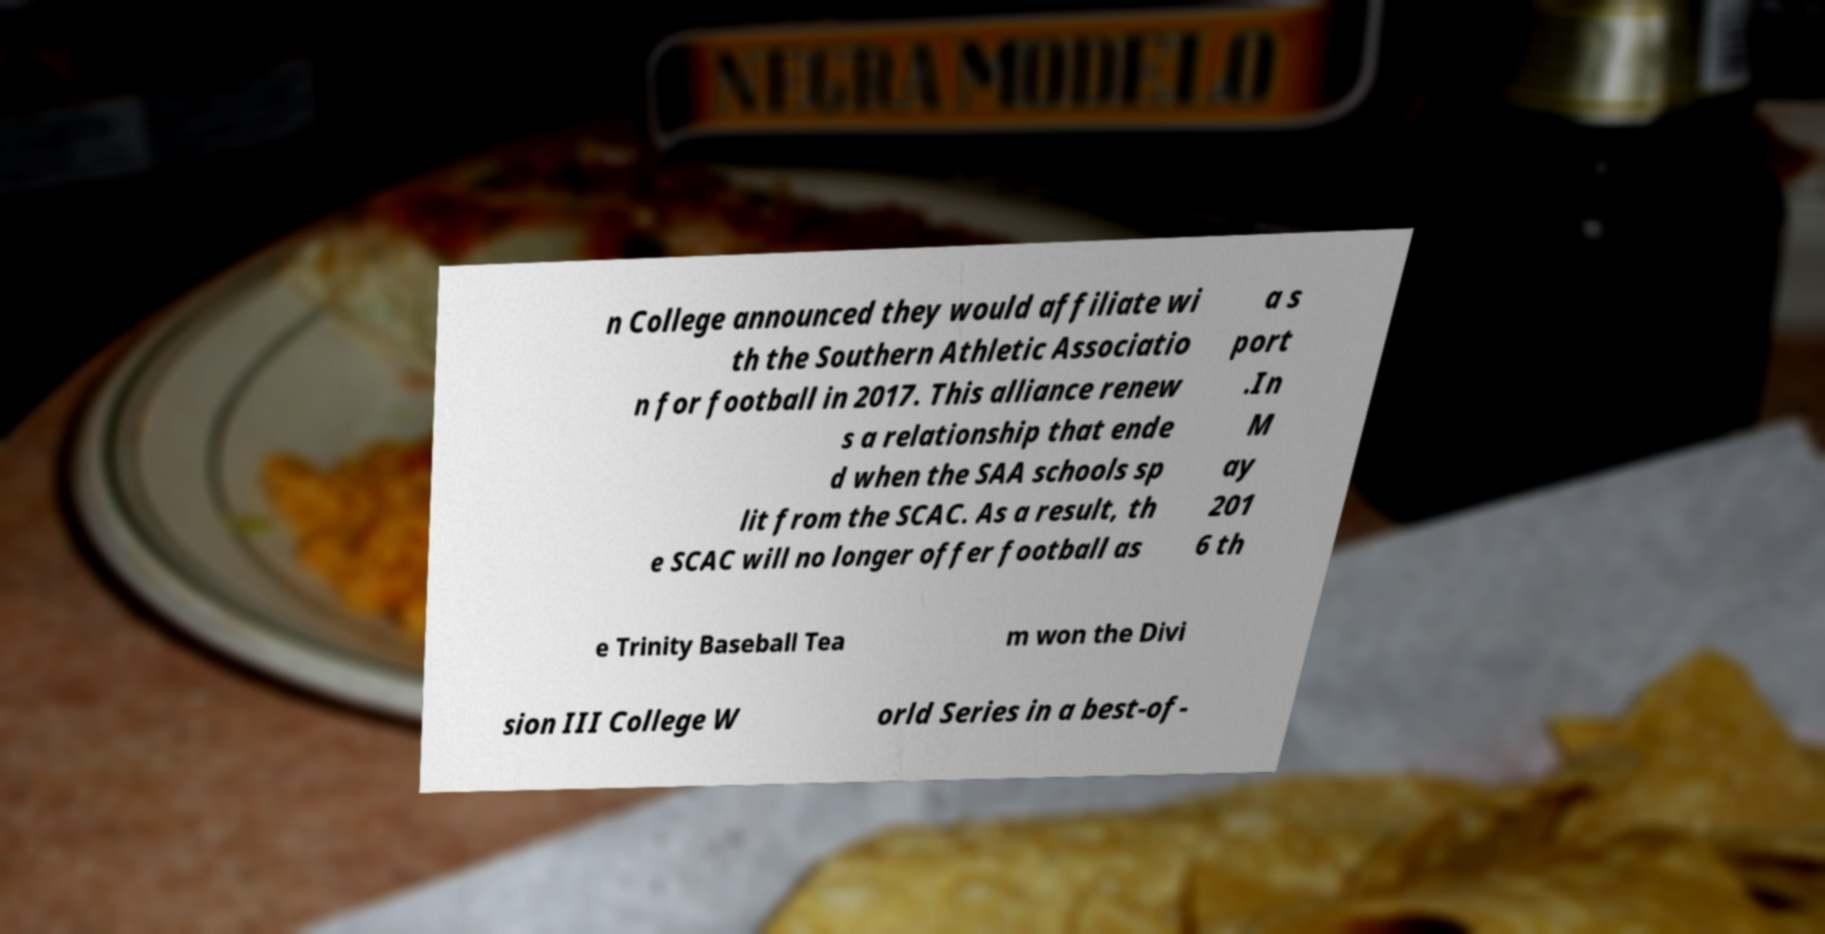For documentation purposes, I need the text within this image transcribed. Could you provide that? n College announced they would affiliate wi th the Southern Athletic Associatio n for football in 2017. This alliance renew s a relationship that ende d when the SAA schools sp lit from the SCAC. As a result, th e SCAC will no longer offer football as a s port .In M ay 201 6 th e Trinity Baseball Tea m won the Divi sion III College W orld Series in a best-of- 